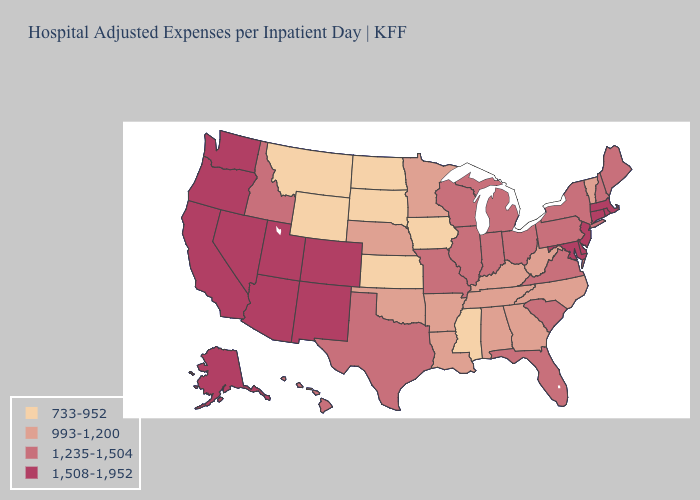Does the first symbol in the legend represent the smallest category?
Short answer required. Yes. Name the states that have a value in the range 733-952?
Write a very short answer. Iowa, Kansas, Mississippi, Montana, North Dakota, South Dakota, Wyoming. What is the value of Oklahoma?
Answer briefly. 993-1,200. Does Washington have the highest value in the West?
Quick response, please. Yes. Does Mississippi have the highest value in the USA?
Quick response, please. No. What is the lowest value in the MidWest?
Be succinct. 733-952. Name the states that have a value in the range 1,508-1,952?
Write a very short answer. Alaska, Arizona, California, Colorado, Connecticut, Delaware, Maryland, Massachusetts, Nevada, New Jersey, New Mexico, Oregon, Rhode Island, Utah, Washington. Name the states that have a value in the range 733-952?
Write a very short answer. Iowa, Kansas, Mississippi, Montana, North Dakota, South Dakota, Wyoming. Name the states that have a value in the range 733-952?
Give a very brief answer. Iowa, Kansas, Mississippi, Montana, North Dakota, South Dakota, Wyoming. Does Oklahoma have a lower value than Arizona?
Be succinct. Yes. How many symbols are there in the legend?
Give a very brief answer. 4. Among the states that border Kentucky , which have the lowest value?
Be succinct. Tennessee, West Virginia. What is the value of Georgia?
Keep it brief. 993-1,200. Name the states that have a value in the range 733-952?
Be succinct. Iowa, Kansas, Mississippi, Montana, North Dakota, South Dakota, Wyoming. How many symbols are there in the legend?
Concise answer only. 4. 